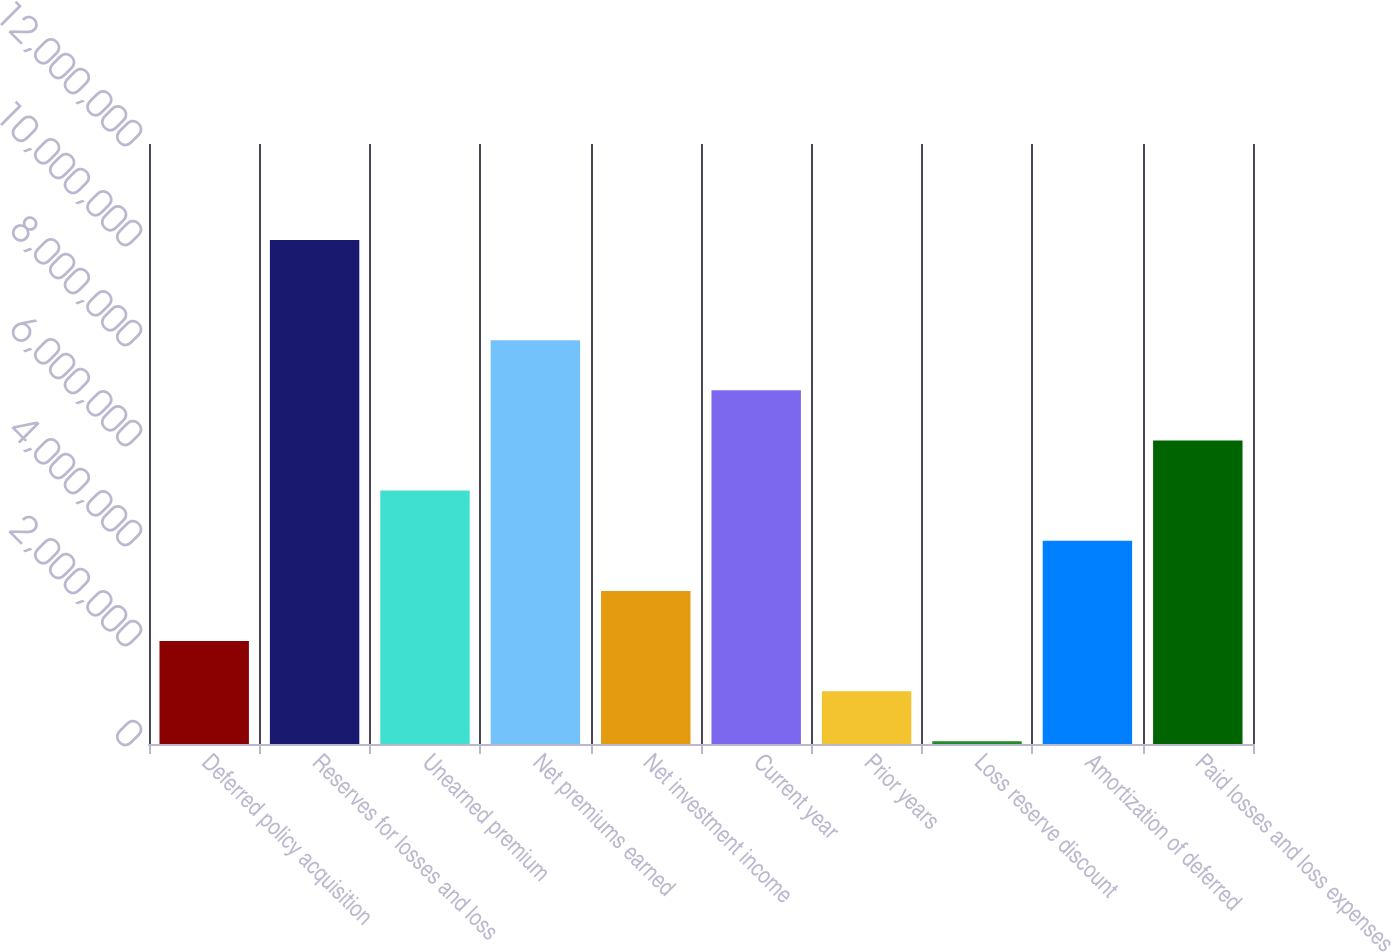Convert chart to OTSL. <chart><loc_0><loc_0><loc_500><loc_500><bar_chart><fcel>Deferred policy acquisition<fcel>Reserves for losses and loss<fcel>Unearned premium<fcel>Net premiums earned<fcel>Net investment income<fcel>Current year<fcel>Prior years<fcel>Loss reserve discount<fcel>Amortization of deferred<fcel>Paid losses and loss expenses<nl><fcel>2.05974e+06<fcel>1.00809e+07<fcel>5.06769e+06<fcel>8.07564e+06<fcel>3.06239e+06<fcel>7.07299e+06<fcel>1.05709e+06<fcel>54441<fcel>4.06504e+06<fcel>6.07034e+06<nl></chart> 